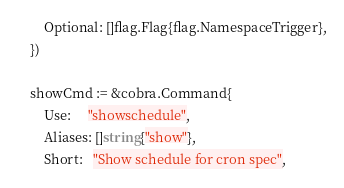Convert code to text. <code><loc_0><loc_0><loc_500><loc_500><_Go_>		Optional: []flag.Flag{flag.NamespaceTrigger},
	})

	showCmd := &cobra.Command{
		Use:     "showschedule",
		Aliases: []string{"show"},
		Short:   "Show schedule for cron spec",</code> 